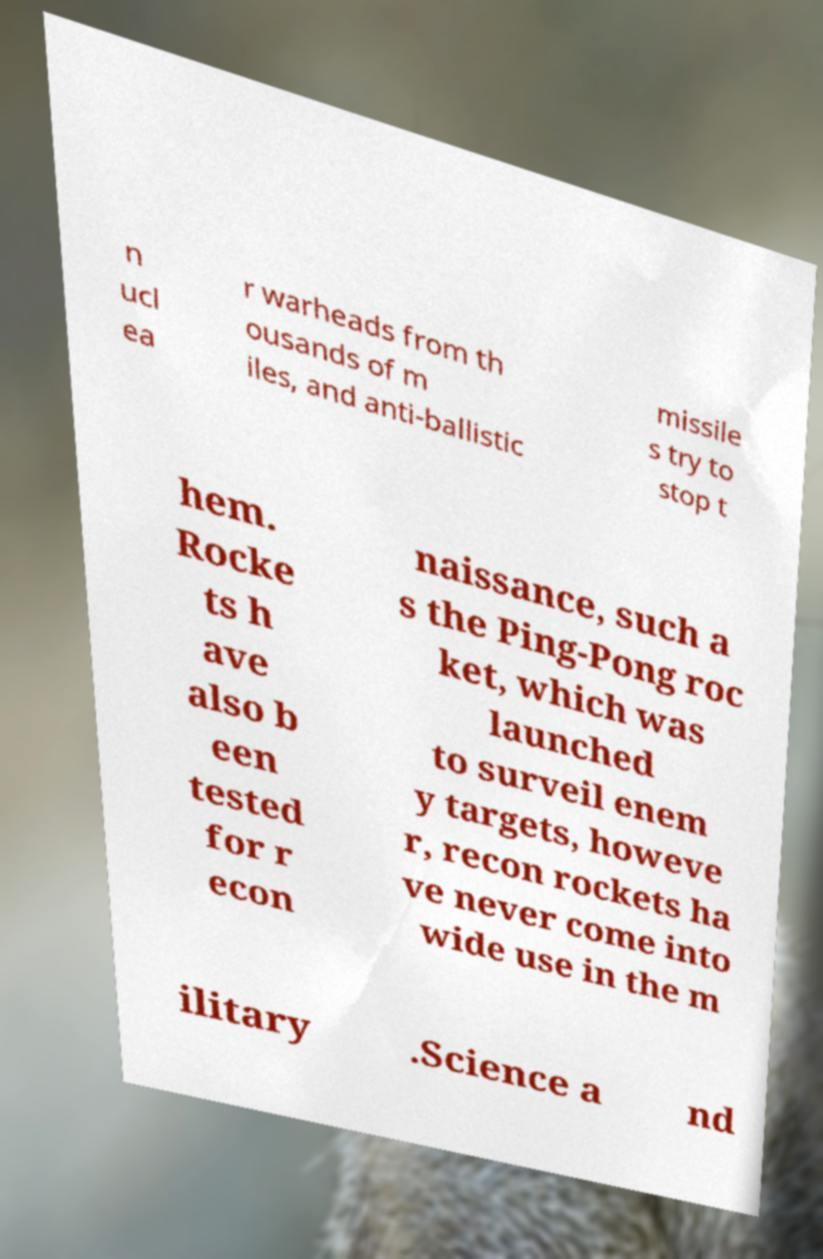For documentation purposes, I need the text within this image transcribed. Could you provide that? n ucl ea r warheads from th ousands of m iles, and anti-ballistic missile s try to stop t hem. Rocke ts h ave also b een tested for r econ naissance, such a s the Ping-Pong roc ket, which was launched to surveil enem y targets, howeve r, recon rockets ha ve never come into wide use in the m ilitary .Science a nd 